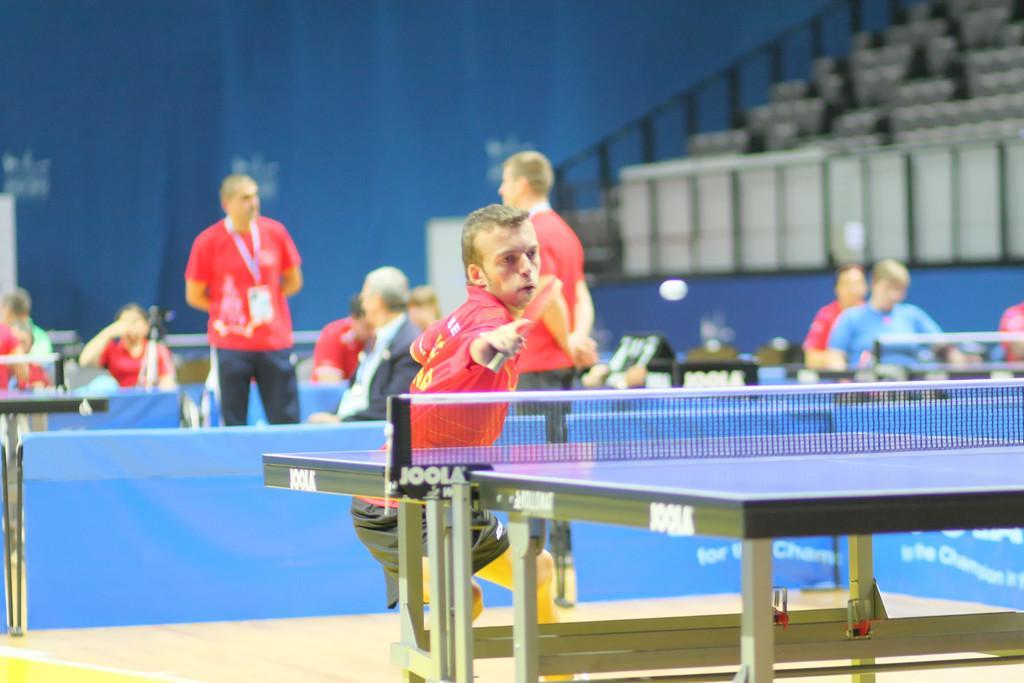In one or two sentences, can you explain what this image depicts? In this image I can see a table-tennis table, a white colored ball and number of persons are standing and sitting. I can see the blurry background in which I can see few chairs in the stadium and the blue colored surface. 